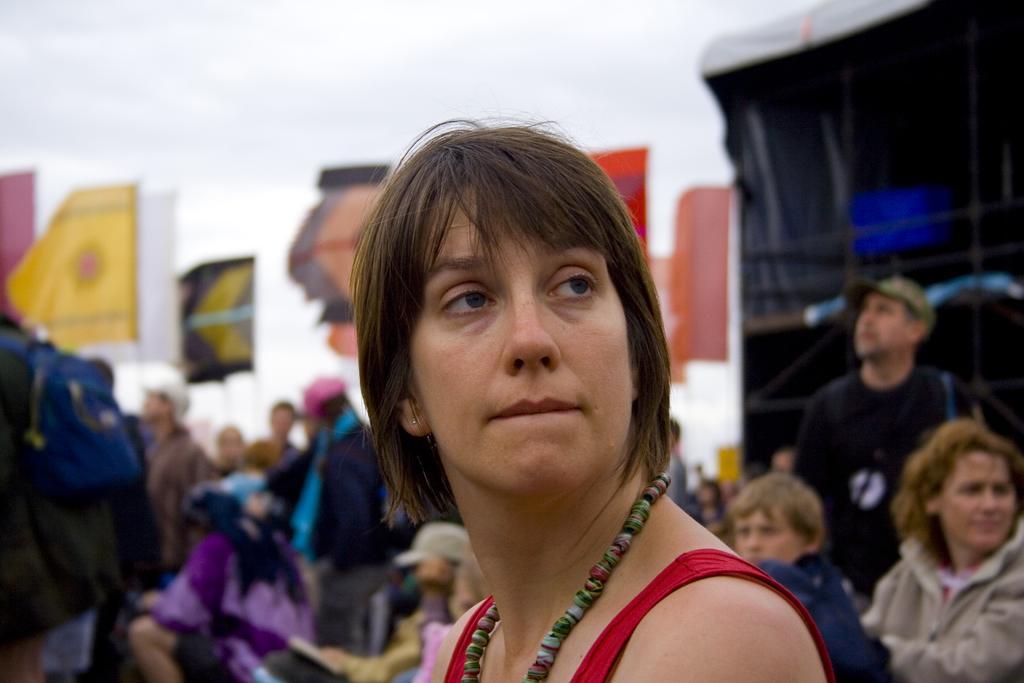Please provide a concise description of this image. In this image we can see a woman. On the backside we can see the flags and a wall. 